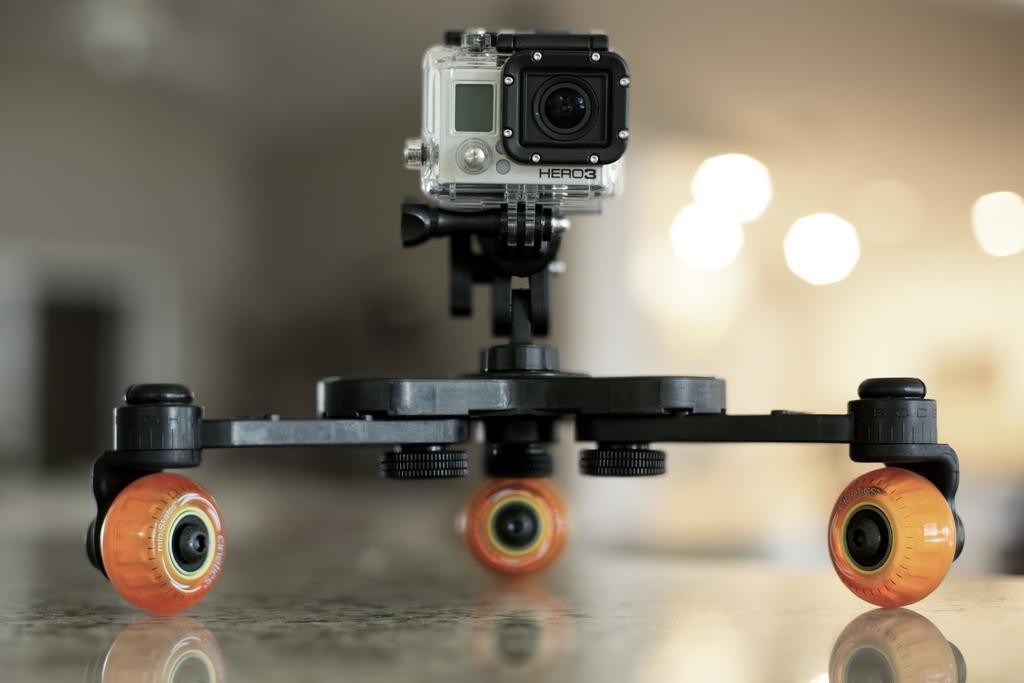Please provide a concise description of this image. Here I can see an electronic gadget which is placed on the floor. At the top of the gadget there is a camera. The background is blurred. 